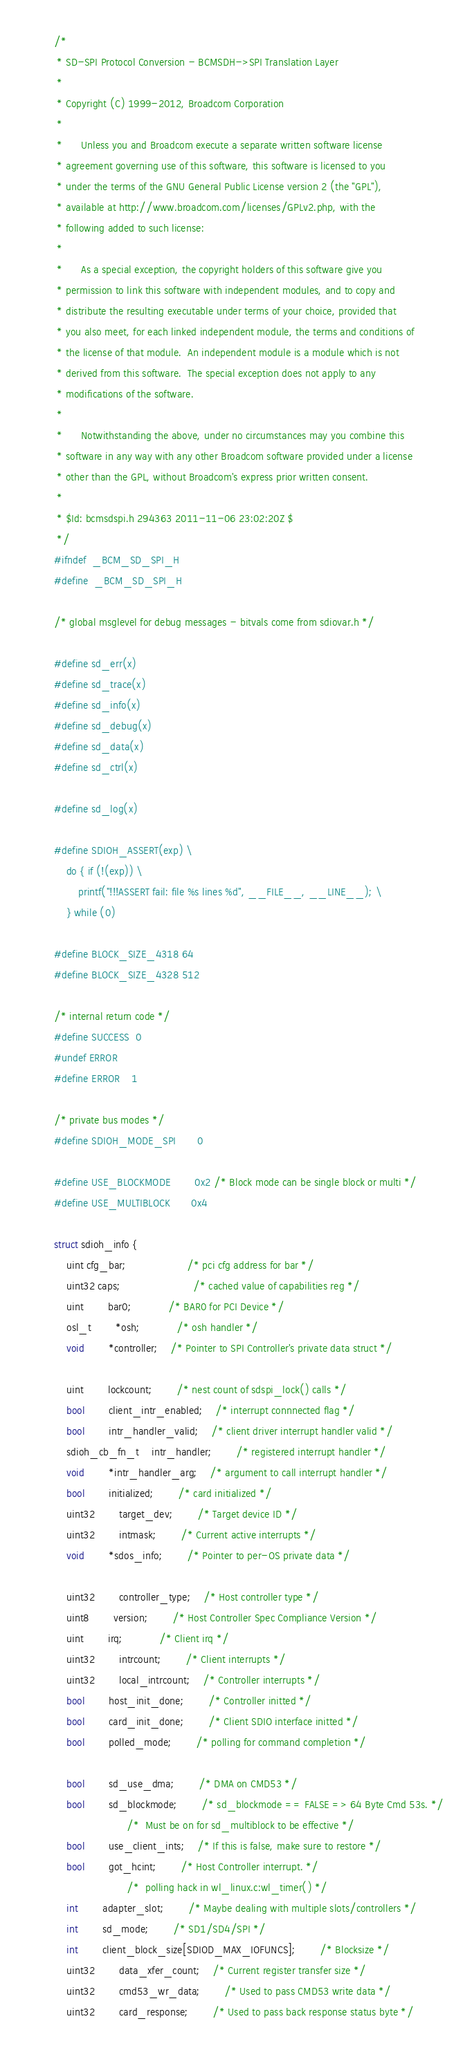<code> <loc_0><loc_0><loc_500><loc_500><_C_>/*
 * SD-SPI Protocol Conversion - BCMSDH->SPI Translation Layer
 *
 * Copyright (C) 1999-2012, Broadcom Corporation
 *
 *      Unless you and Broadcom execute a separate written software license
 * agreement governing use of this software, this software is licensed to you
 * under the terms of the GNU General Public License version 2 (the "GPL"),
 * available at http://www.broadcom.com/licenses/GPLv2.php, with the
 * following added to such license:
 *
 *      As a special exception, the copyright holders of this software give you
 * permission to link this software with independent modules, and to copy and
 * distribute the resulting executable under terms of your choice, provided that
 * you also meet, for each linked independent module, the terms and conditions of
 * the license of that module.  An independent module is a module which is not
 * derived from this software.  The special exception does not apply to any
 * modifications of the software.
 *
 *      Notwithstanding the above, under no circumstances may you combine this
 * software in any way with any other Broadcom software provided under a license
 * other than the GPL, without Broadcom's express prior written consent.
 *
 * $Id: bcmsdspi.h 294363 2011-11-06 23:02:20Z $
 */
#ifndef	_BCM_SD_SPI_H
#define	_BCM_SD_SPI_H

/* global msglevel for debug messages - bitvals come from sdiovar.h */

#define sd_err(x)
#define sd_trace(x)
#define sd_info(x)
#define sd_debug(x)
#define sd_data(x)
#define sd_ctrl(x)

#define sd_log(x)

#define SDIOH_ASSERT(exp) \
	do { if (!(exp)) \
		printf("!!!ASSERT fail: file %s lines %d", __FILE__, __LINE__); \
	} while (0)

#define BLOCK_SIZE_4318 64
#define BLOCK_SIZE_4328 512

/* internal return code */
#define SUCCESS	0
#undef ERROR
#define ERROR	1

/* private bus modes */
#define SDIOH_MODE_SPI		0

#define USE_BLOCKMODE		0x2	/* Block mode can be single block or multi */
#define USE_MULTIBLOCK		0x4

struct sdioh_info {
	uint cfg_bar;                   	/* pci cfg address for bar */
	uint32 caps;                    	/* cached value of capabilities reg */
	uint		bar0;			/* BAR0 for PCI Device */
	osl_t 		*osh;			/* osh handler */
	void		*controller;	/* Pointer to SPI Controller's private data struct */

	uint		lockcount; 		/* nest count of sdspi_lock() calls */
	bool		client_intr_enabled;	/* interrupt connnected flag */
	bool		intr_handler_valid;	/* client driver interrupt handler valid */
	sdioh_cb_fn_t	intr_handler;		/* registered interrupt handler */
	void		*intr_handler_arg;	/* argument to call interrupt handler */
	bool		initialized;		/* card initialized */
	uint32		target_dev;		/* Target device ID */
	uint32		intmask;		/* Current active interrupts */
	void		*sdos_info;		/* Pointer to per-OS private data */

	uint32		controller_type;	/* Host controller type */
	uint8		version;		/* Host Controller Spec Compliance Version */
	uint 		irq;			/* Client irq */
	uint32 		intrcount;		/* Client interrupts */
	uint32 		local_intrcount;	/* Controller interrupts */
	bool 		host_init_done;		/* Controller initted */
	bool 		card_init_done;		/* Client SDIO interface initted */
	bool 		polled_mode;		/* polling for command completion */

	bool		sd_use_dma;		/* DMA on CMD53 */
	bool 		sd_blockmode;		/* sd_blockmode == FALSE => 64 Byte Cmd 53s. */
						/*  Must be on for sd_multiblock to be effective */
	bool 		use_client_ints;	/* If this is false, make sure to restore */
	bool		got_hcint;		/* Host Controller interrupt. */
						/*  polling hack in wl_linux.c:wl_timer() */
	int 		adapter_slot;		/* Maybe dealing with multiple slots/controllers */
	int 		sd_mode;		/* SD1/SD4/SPI */
	int 		client_block_size[SDIOD_MAX_IOFUNCS];		/* Blocksize */
	uint32 		data_xfer_count;	/* Current register transfer size */
	uint32		cmd53_wr_data;		/* Used to pass CMD53 write data */
	uint32		card_response;		/* Used to pass back response status byte */</code> 